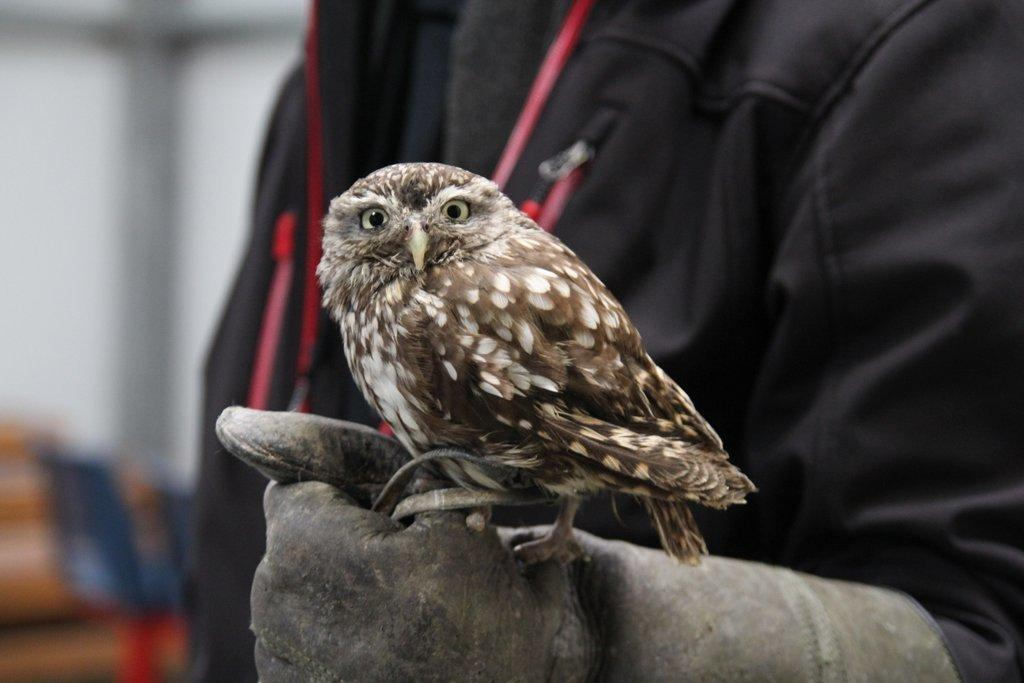Who is present in the image? There is a man in the image. What is the man wearing? The man is wearing a jacket and gloves. What animal is in the image? There is an owl in the image. Where is the owl positioned in relation to the man? The owl is standing on the gloves. What is on the left side of the image? There is a wall and chairs on the left side of the image. What type of root can be seen growing from the man's jacket in the image? There is no root growing from the man's jacket in the image. What is the owl using to perform calculations in the image? The owl is not using a calculator in the image; it is simply standing on the gloves. 